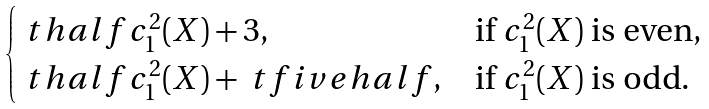Convert formula to latex. <formula><loc_0><loc_0><loc_500><loc_500>\begin{cases} \ t h a l f c _ { 1 } ^ { 2 } ( X ) + 3 , & \text {if $c_{1}^{2}(X)$ is even} , \\ \ t h a l f c _ { 1 } ^ { 2 } ( X ) + \ t f i v e h a l f , & \text {if $c_{1}^{2}(X)$ is odd} . \end{cases}</formula> 